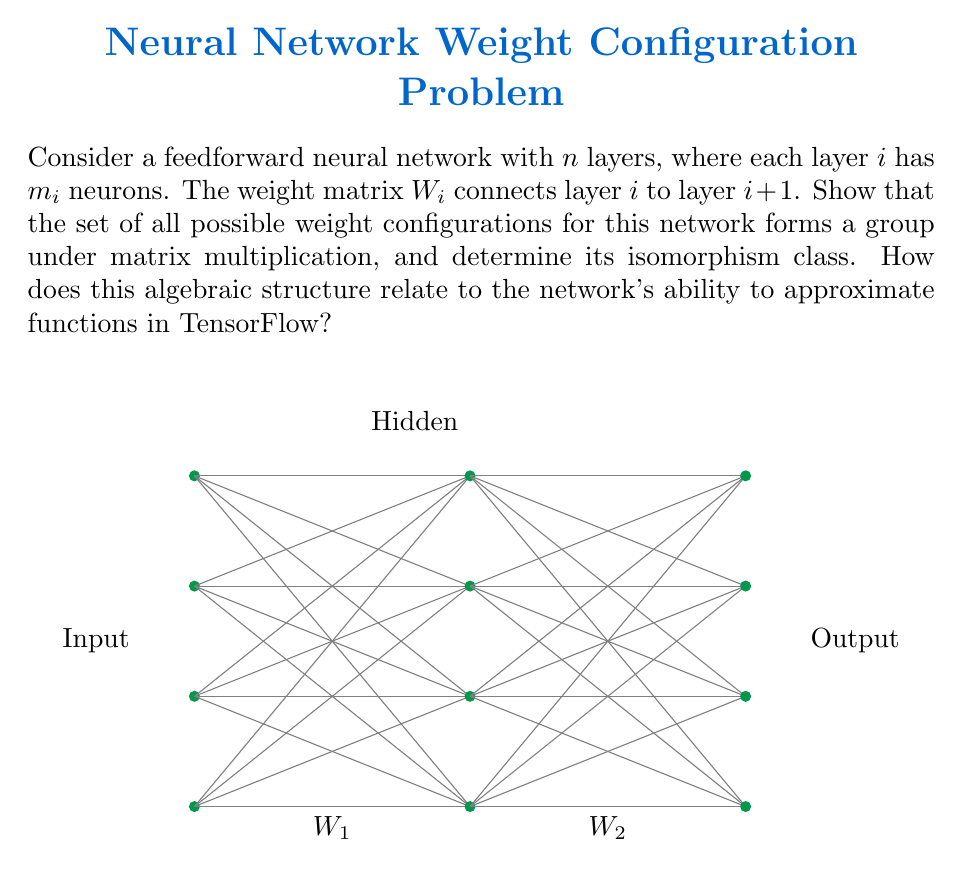Can you solve this math problem? Let's approach this step-by-step:

1) First, we need to understand the structure of the weight matrices:
   - $W_i$ is an $m_{i+1} \times m_i$ matrix for $i = 1, 2, ..., n-1$
   - The set of all possible weight configurations is the Cartesian product:
     $$G = \prod_{i=1}^{n-1} \mathbb{R}^{m_{i+1} \times m_i}$$

2) To show that $G$ forms a group under matrix multiplication:
   a) Closure: The product of two elements in $G$ is still in $G$
   b) Associativity: Matrix multiplication is associative
   c) Identity: The identity element is $(I_{m_2}, I_{m_3}, ..., I_{m_n})$
   d) Inverse: Each matrix in the product has an inverse (assuming non-zero determinant)

3) The isomorphism class of $G$ is:
   $$G \cong GL(m_2, \mathbb{R}) \times GL(m_3, \mathbb{R}) \times ... \times GL(m_n, \mathbb{R})$$
   where $GL(m, \mathbb{R})$ is the general linear group of degree $m$ over $\mathbb{R}$

4) This algebraic structure relates to the network's function approximation ability in TensorFlow:
   - The group structure allows for smooth parameter updates during training
   - The dimensionality of the group (sum of $m_i \times m_{i+1}$) determines the network's capacity
   - The continuous nature of $\mathbb{R}$ allows for arbitrarily close approximations of target functions

5) In TensorFlow, this structure is implicitly used in:
   - Weight initialization (sampling from the group)
   - Gradient descent (moving along the group manifold)
   - Regularization techniques (constraining weights to subsets of the group)
Answer: $G \cong \prod_{i=1}^{n-1} GL(m_{i+1}, \mathbb{R})$ 